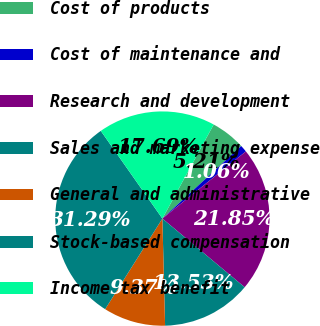Convert chart to OTSL. <chart><loc_0><loc_0><loc_500><loc_500><pie_chart><fcel>Cost of products<fcel>Cost of maintenance and<fcel>Research and development<fcel>Sales and marketing expense<fcel>General and administrative<fcel>Stock-based compensation<fcel>Income tax benefit<nl><fcel>5.21%<fcel>1.06%<fcel>21.85%<fcel>13.53%<fcel>9.37%<fcel>31.29%<fcel>17.69%<nl></chart> 